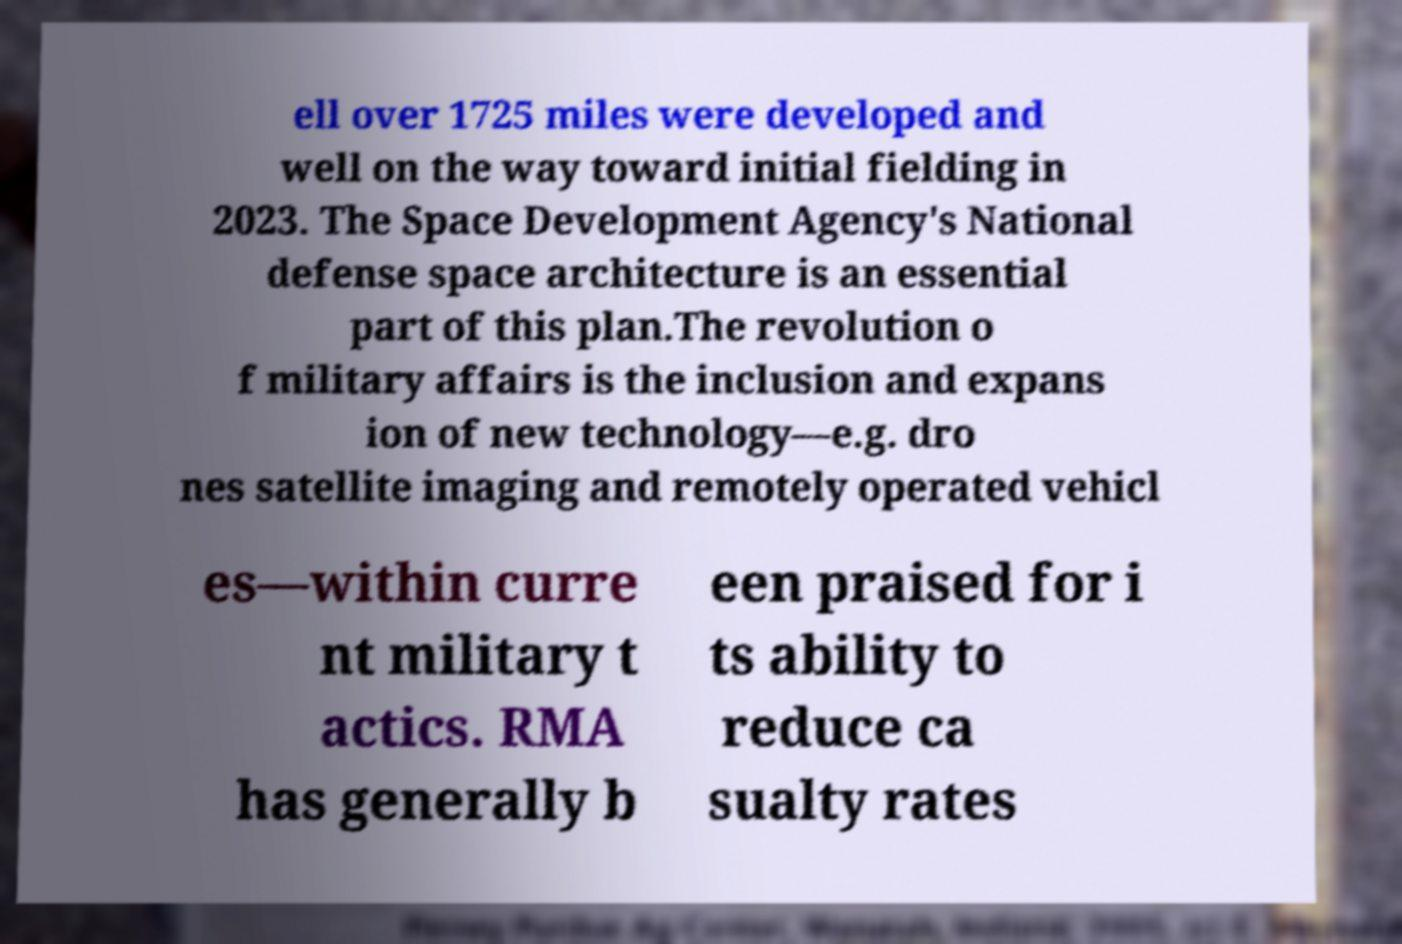Can you accurately transcribe the text from the provided image for me? ell over 1725 miles were developed and well on the way toward initial fielding in 2023. The Space Development Agency's National defense space architecture is an essential part of this plan.The revolution o f military affairs is the inclusion and expans ion of new technology—e.g. dro nes satellite imaging and remotely operated vehicl es—within curre nt military t actics. RMA has generally b een praised for i ts ability to reduce ca sualty rates 